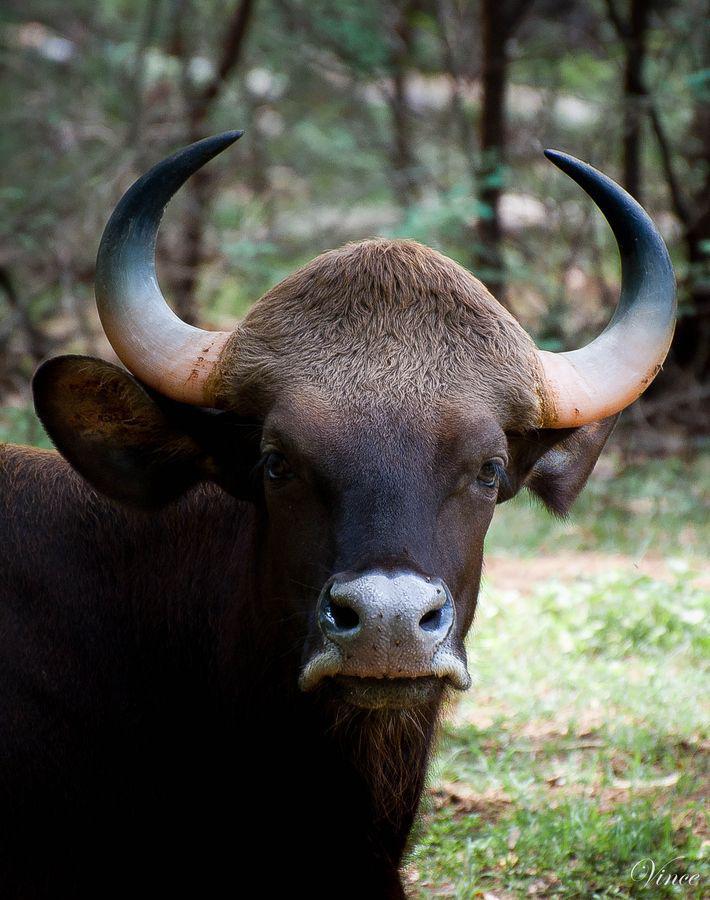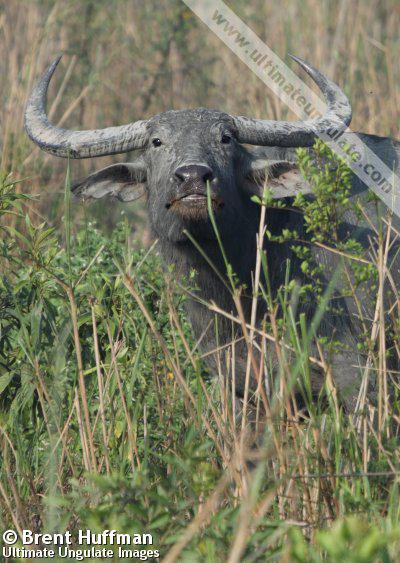The first image is the image on the left, the second image is the image on the right. Considering the images on both sides, is "In each image the water buffalo's horns are completely visible." valid? Answer yes or no. Yes. The first image is the image on the left, the second image is the image on the right. Assess this claim about the two images: "The horned animal on the left looks directly at the camera.". Correct or not? Answer yes or no. Yes. 